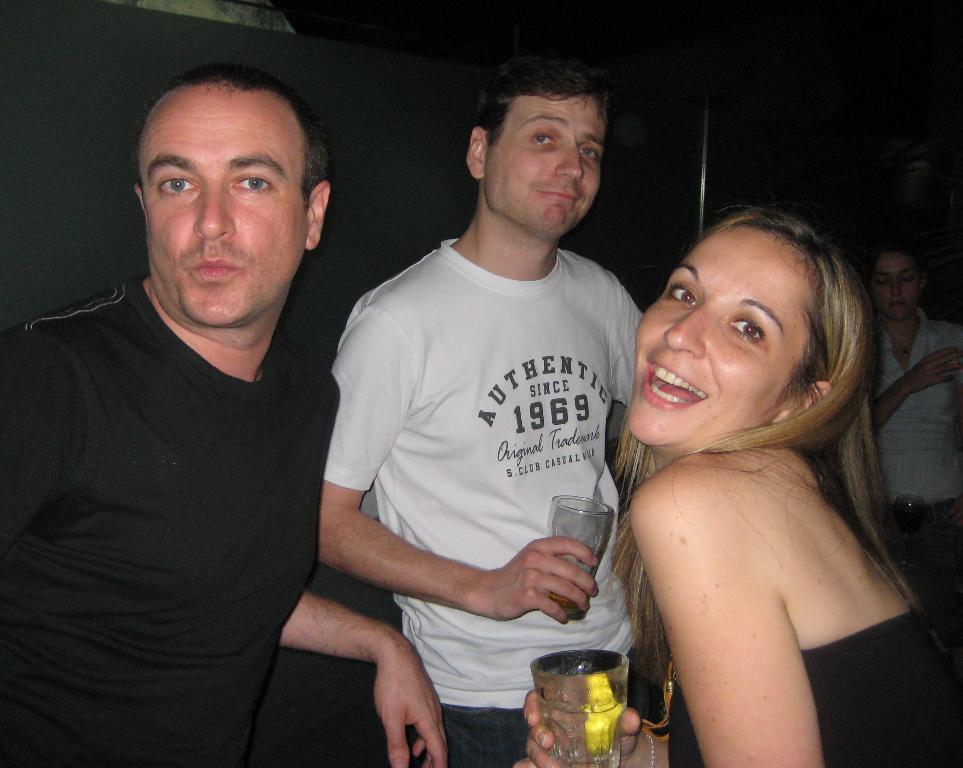How many people are present in the image? There are four people in the image. What are two of the people doing with their hands? Two of the people are holding glasses. What is the facial expression of the people holding glasses? The people holding glasses are smiling. What can be observed about the lighting in the image? The background of the image is dark. How many trees can be seen in the image? There are no trees visible in the image. Is there a jail in the background of the image? There is no jail present in the image. 